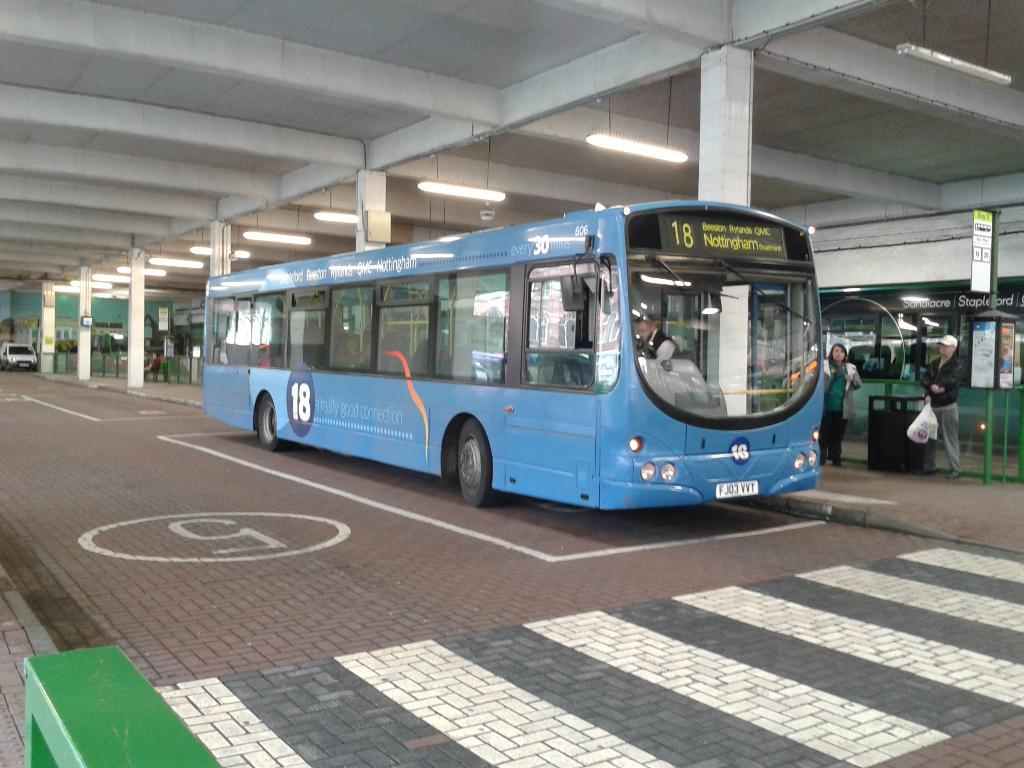What types of objects can be seen in the image? There are vehicles, persons, pillars, tube lights, poles, boards with text, and a building in the image. Can you describe the people in the image? There are persons in the image, but their specific actions or characteristics are not mentioned in the facts. What type of lighting is present in the image? Tube lights are present in the image. What architectural features can be seen in the image? Pillars, poles, and a building are visible in the image. What type of signage is present in the image? Boards with text are present in the image. Can you see anyone breathing ice in the image? There is no mention of ice or anyone breathing in the image. Is there a swing present in the image? There is no mention of a swing in the image. 